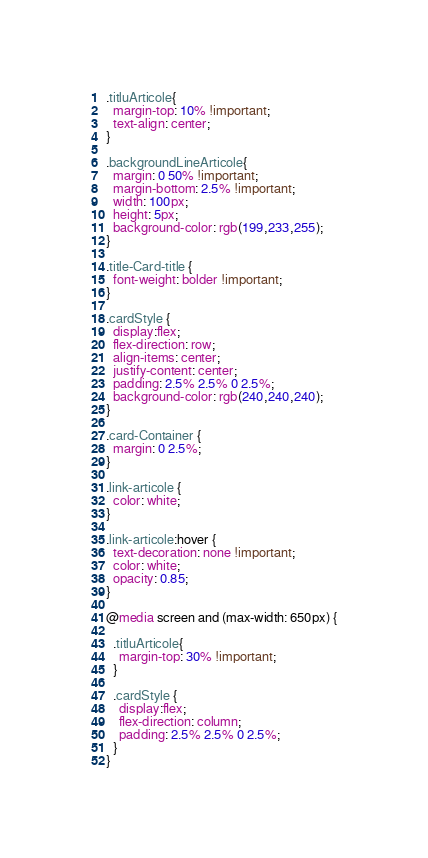Convert code to text. <code><loc_0><loc_0><loc_500><loc_500><_CSS_>.titluArticole{
  margin-top: 10% !important;
  text-align: center;
}

.backgroundLineArticole{
  margin: 0 50% !important;
  margin-bottom: 2.5% !important;
  width: 100px;
  height: 5px;
  background-color: rgb(199,233,255);
}

.title-Card-title {
  font-weight: bolder !important;
}

.cardStyle {
  display:flex;
  flex-direction: row;
  align-items: center;
  justify-content: center;
  padding: 2.5% 2.5% 0 2.5%;
  background-color: rgb(240,240,240);
}

.card-Container {
  margin: 0 2.5%;
}

.link-articole {
  color: white;
}

.link-articole:hover {
  text-decoration: none !important;
  color: white;
  opacity: 0.85;
}

@media screen and (max-width: 650px) {

  .titluArticole{
    margin-top: 30% !important;
  }

  .cardStyle {
    display:flex;
    flex-direction: column;
    padding: 2.5% 2.5% 0 2.5%;
  }
}</code> 